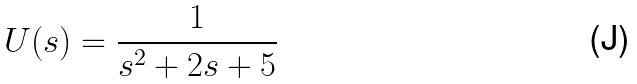Convert formula to latex. <formula><loc_0><loc_0><loc_500><loc_500>U ( s ) = \frac { 1 } { s ^ { 2 } + 2 s + 5 }</formula> 